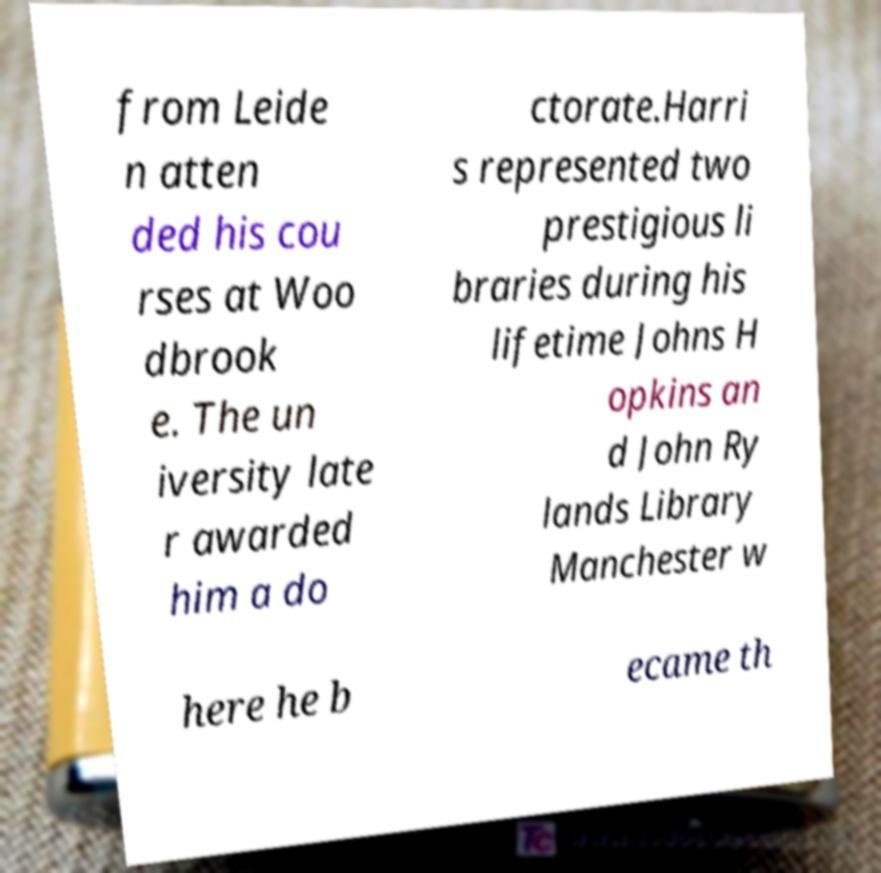Could you assist in decoding the text presented in this image and type it out clearly? from Leide n atten ded his cou rses at Woo dbrook e. The un iversity late r awarded him a do ctorate.Harri s represented two prestigious li braries during his lifetime Johns H opkins an d John Ry lands Library Manchester w here he b ecame th 